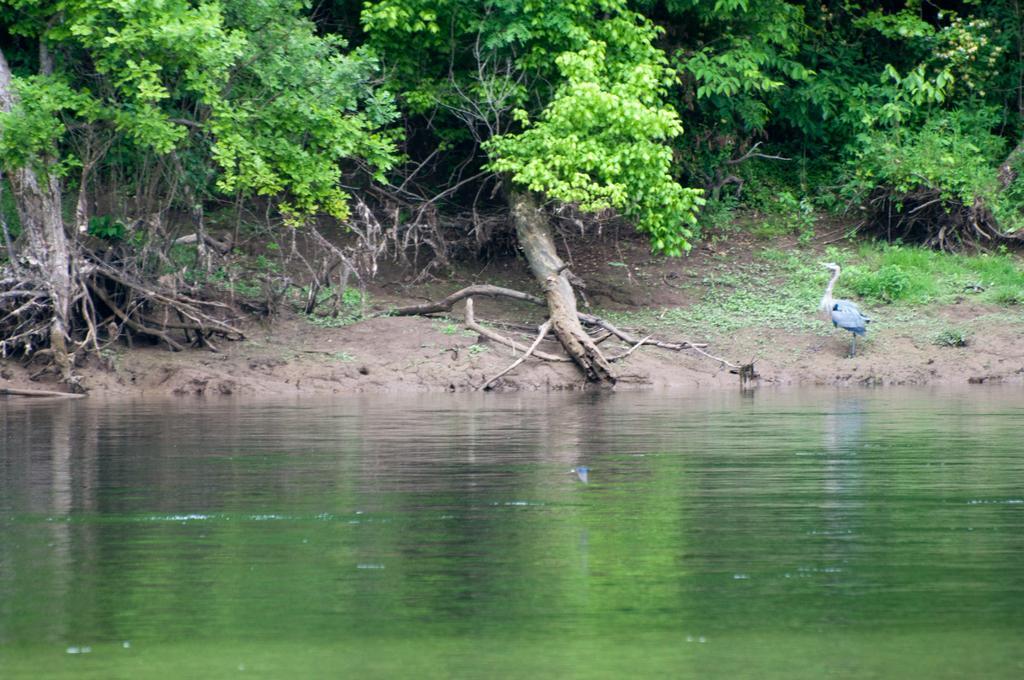Describe this image in one or two sentences. In this image at front there is water. At the back side there are trees and we can see a crane on the sand. 